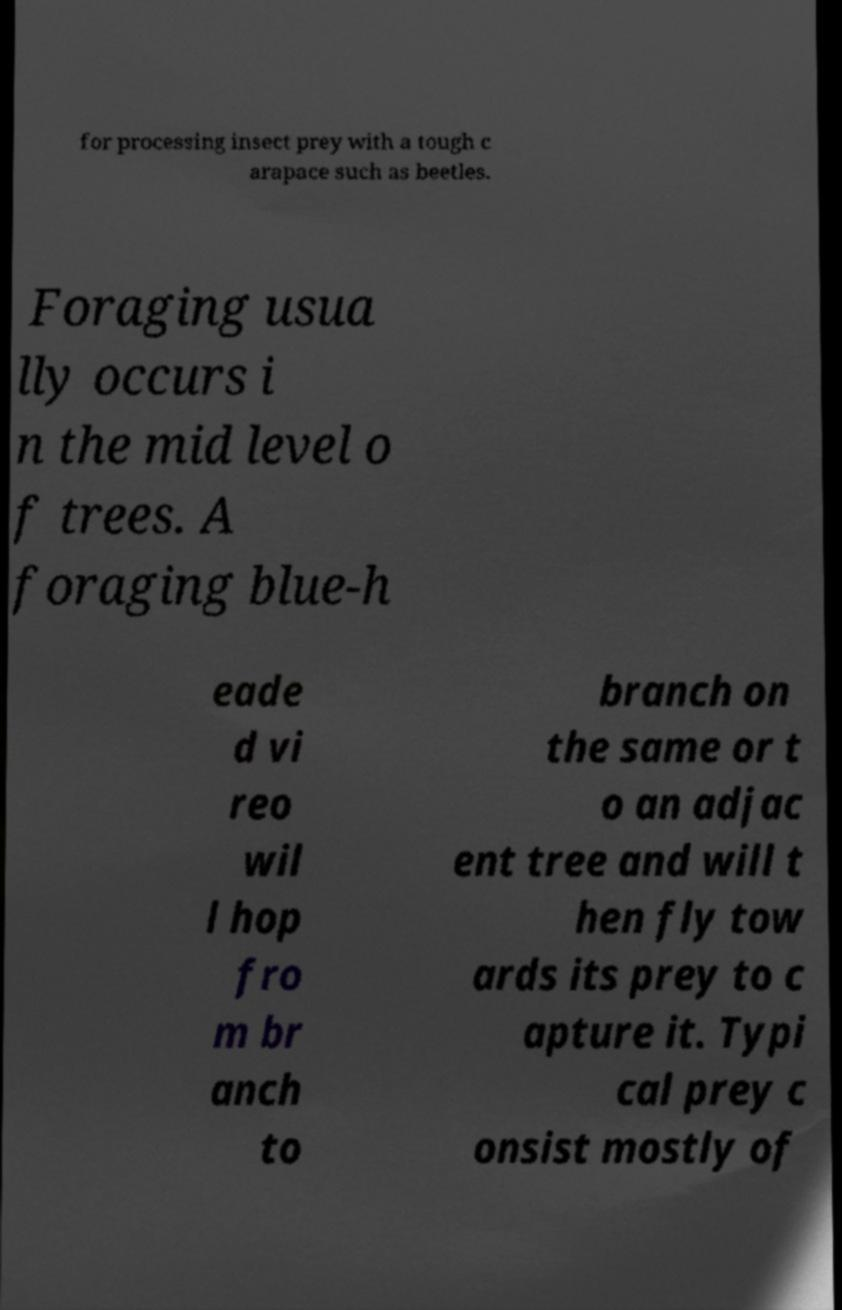Please identify and transcribe the text found in this image. for processing insect prey with a tough c arapace such as beetles. Foraging usua lly occurs i n the mid level o f trees. A foraging blue-h eade d vi reo wil l hop fro m br anch to branch on the same or t o an adjac ent tree and will t hen fly tow ards its prey to c apture it. Typi cal prey c onsist mostly of 